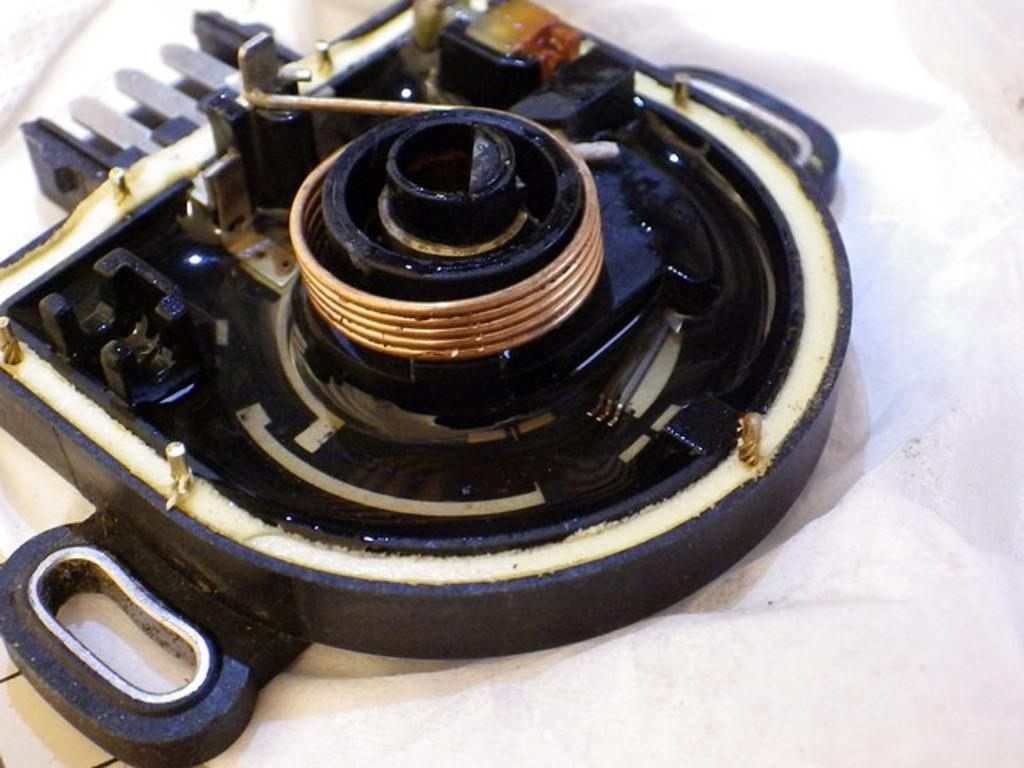What type of tool is present in the image? There is a tool with copper winding in the image. Can you describe the color of the cloth on the right side of the image? The cloth on the right side of the image is white. How many dolls are sitting on the authority figure's lap in the image? There are no dolls or authority figures present in the image. What type of ring is visible on the tool in the image? There is no ring present on the tool in the image; it has copper winding. 